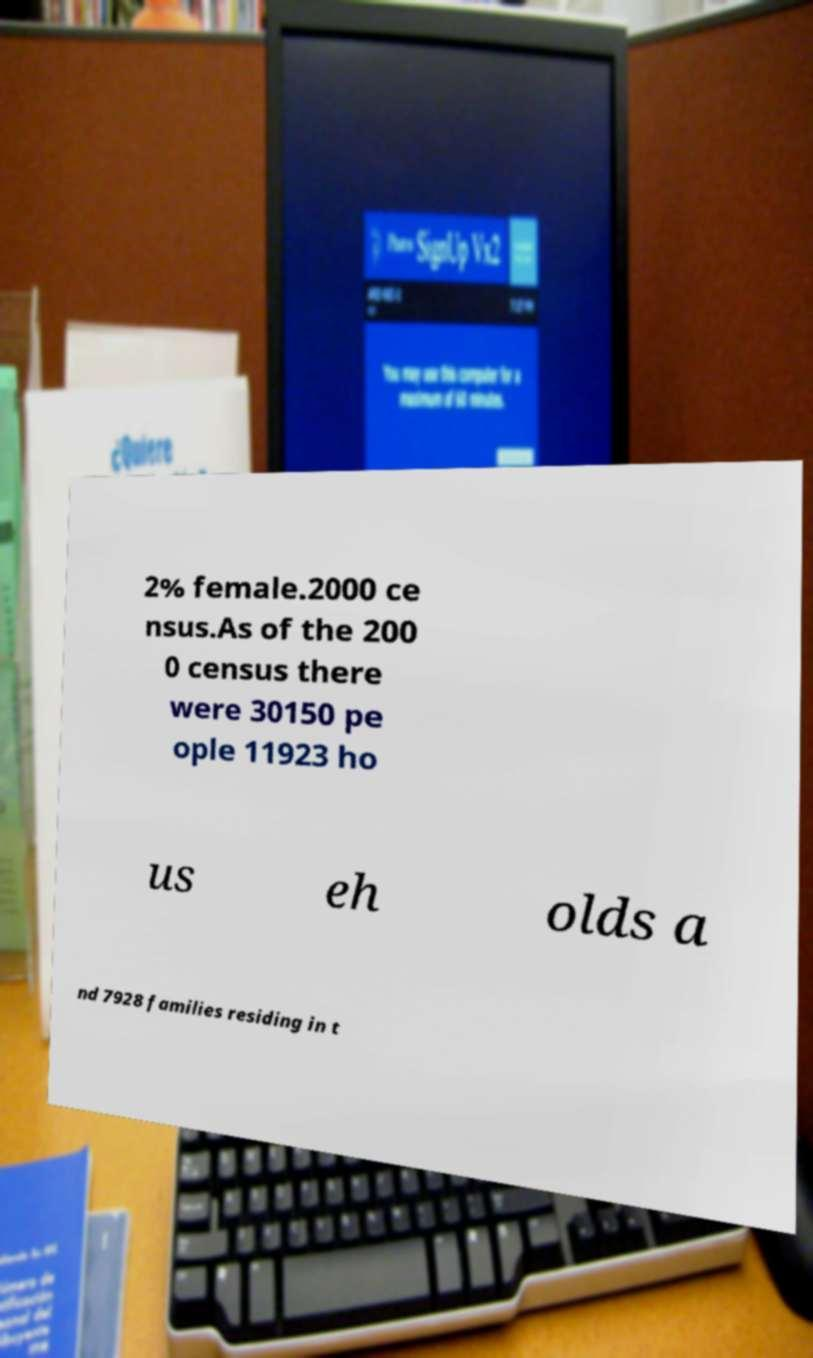Please read and relay the text visible in this image. What does it say? 2% female.2000 ce nsus.As of the 200 0 census there were 30150 pe ople 11923 ho us eh olds a nd 7928 families residing in t 